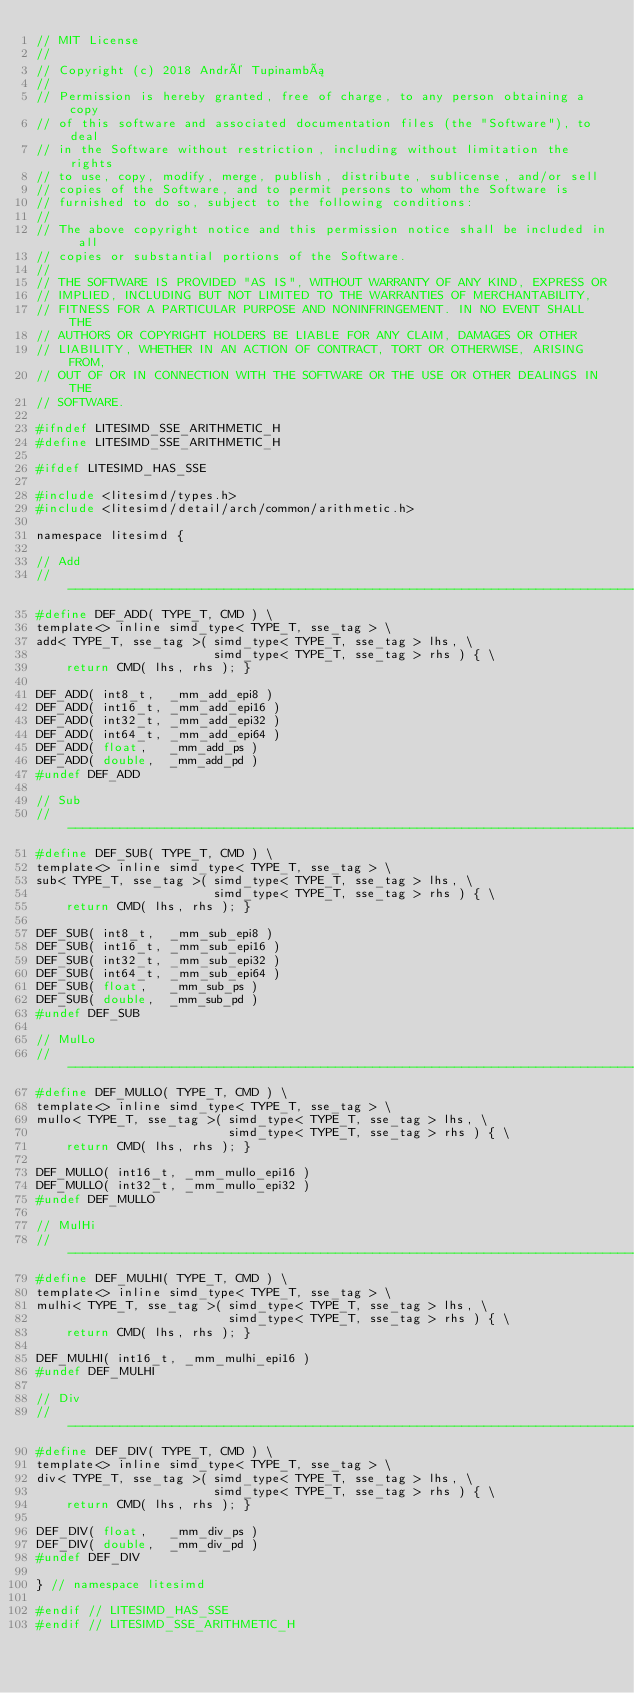<code> <loc_0><loc_0><loc_500><loc_500><_C_>// MIT License
//
// Copyright (c) 2018 André Tupinambá
//
// Permission is hereby granted, free of charge, to any person obtaining a copy
// of this software and associated documentation files (the "Software"), to deal
// in the Software without restriction, including without limitation the rights
// to use, copy, modify, merge, publish, distribute, sublicense, and/or sell
// copies of the Software, and to permit persons to whom the Software is
// furnished to do so, subject to the following conditions:
//
// The above copyright notice and this permission notice shall be included in all
// copies or substantial portions of the Software.
//
// THE SOFTWARE IS PROVIDED "AS IS", WITHOUT WARRANTY OF ANY KIND, EXPRESS OR
// IMPLIED, INCLUDING BUT NOT LIMITED TO THE WARRANTIES OF MERCHANTABILITY,
// FITNESS FOR A PARTICULAR PURPOSE AND NONINFRINGEMENT. IN NO EVENT SHALL THE
// AUTHORS OR COPYRIGHT HOLDERS BE LIABLE FOR ANY CLAIM, DAMAGES OR OTHER
// LIABILITY, WHETHER IN AN ACTION OF CONTRACT, TORT OR OTHERWISE, ARISING FROM,
// OUT OF OR IN CONNECTION WITH THE SOFTWARE OR THE USE OR OTHER DEALINGS IN THE
// SOFTWARE.

#ifndef LITESIMD_SSE_ARITHMETIC_H
#define LITESIMD_SSE_ARITHMETIC_H

#ifdef LITESIMD_HAS_SSE

#include <litesimd/types.h>
#include <litesimd/detail/arch/common/arithmetic.h>

namespace litesimd {

// Add
// ---------------------------------------------------------------------------------------
#define DEF_ADD( TYPE_T, CMD ) \
template<> inline simd_type< TYPE_T, sse_tag > \
add< TYPE_T, sse_tag >( simd_type< TYPE_T, sse_tag > lhs, \
                        simd_type< TYPE_T, sse_tag > rhs ) { \
    return CMD( lhs, rhs ); }

DEF_ADD( int8_t,  _mm_add_epi8 )
DEF_ADD( int16_t, _mm_add_epi16 )
DEF_ADD( int32_t, _mm_add_epi32 )
DEF_ADD( int64_t, _mm_add_epi64 )
DEF_ADD( float,   _mm_add_ps )
DEF_ADD( double,  _mm_add_pd )
#undef DEF_ADD

// Sub
// ---------------------------------------------------------------------------------------
#define DEF_SUB( TYPE_T, CMD ) \
template<> inline simd_type< TYPE_T, sse_tag > \
sub< TYPE_T, sse_tag >( simd_type< TYPE_T, sse_tag > lhs, \
                        simd_type< TYPE_T, sse_tag > rhs ) { \
    return CMD( lhs, rhs ); }

DEF_SUB( int8_t,  _mm_sub_epi8 )
DEF_SUB( int16_t, _mm_sub_epi16 )
DEF_SUB( int32_t, _mm_sub_epi32 )
DEF_SUB( int64_t, _mm_sub_epi64 )
DEF_SUB( float,   _mm_sub_ps )
DEF_SUB( double,  _mm_sub_pd )
#undef DEF_SUB

// MulLo
// ---------------------------------------------------------------------------------------
#define DEF_MULLO( TYPE_T, CMD ) \
template<> inline simd_type< TYPE_T, sse_tag > \
mullo< TYPE_T, sse_tag >( simd_type< TYPE_T, sse_tag > lhs, \
                          simd_type< TYPE_T, sse_tag > rhs ) { \
    return CMD( lhs, rhs ); }

DEF_MULLO( int16_t, _mm_mullo_epi16 )
DEF_MULLO( int32_t, _mm_mullo_epi32 )
#undef DEF_MULLO

// MulHi
// ---------------------------------------------------------------------------------------
#define DEF_MULHI( TYPE_T, CMD ) \
template<> inline simd_type< TYPE_T, sse_tag > \
mulhi< TYPE_T, sse_tag >( simd_type< TYPE_T, sse_tag > lhs, \
                          simd_type< TYPE_T, sse_tag > rhs ) { \
    return CMD( lhs, rhs ); }

DEF_MULHI( int16_t, _mm_mulhi_epi16 )
#undef DEF_MULHI

// Div
// ---------------------------------------------------------------------------------------
#define DEF_DIV( TYPE_T, CMD ) \
template<> inline simd_type< TYPE_T, sse_tag > \
div< TYPE_T, sse_tag >( simd_type< TYPE_T, sse_tag > lhs, \
                        simd_type< TYPE_T, sse_tag > rhs ) { \
    return CMD( lhs, rhs ); }

DEF_DIV( float,   _mm_div_ps )
DEF_DIV( double,  _mm_div_pd )
#undef DEF_DIV

} // namespace litesimd

#endif // LITESIMD_HAS_SSE
#endif // LITESIMD_SSE_ARITHMETIC_H
</code> 